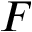<formula> <loc_0><loc_0><loc_500><loc_500>F</formula> 